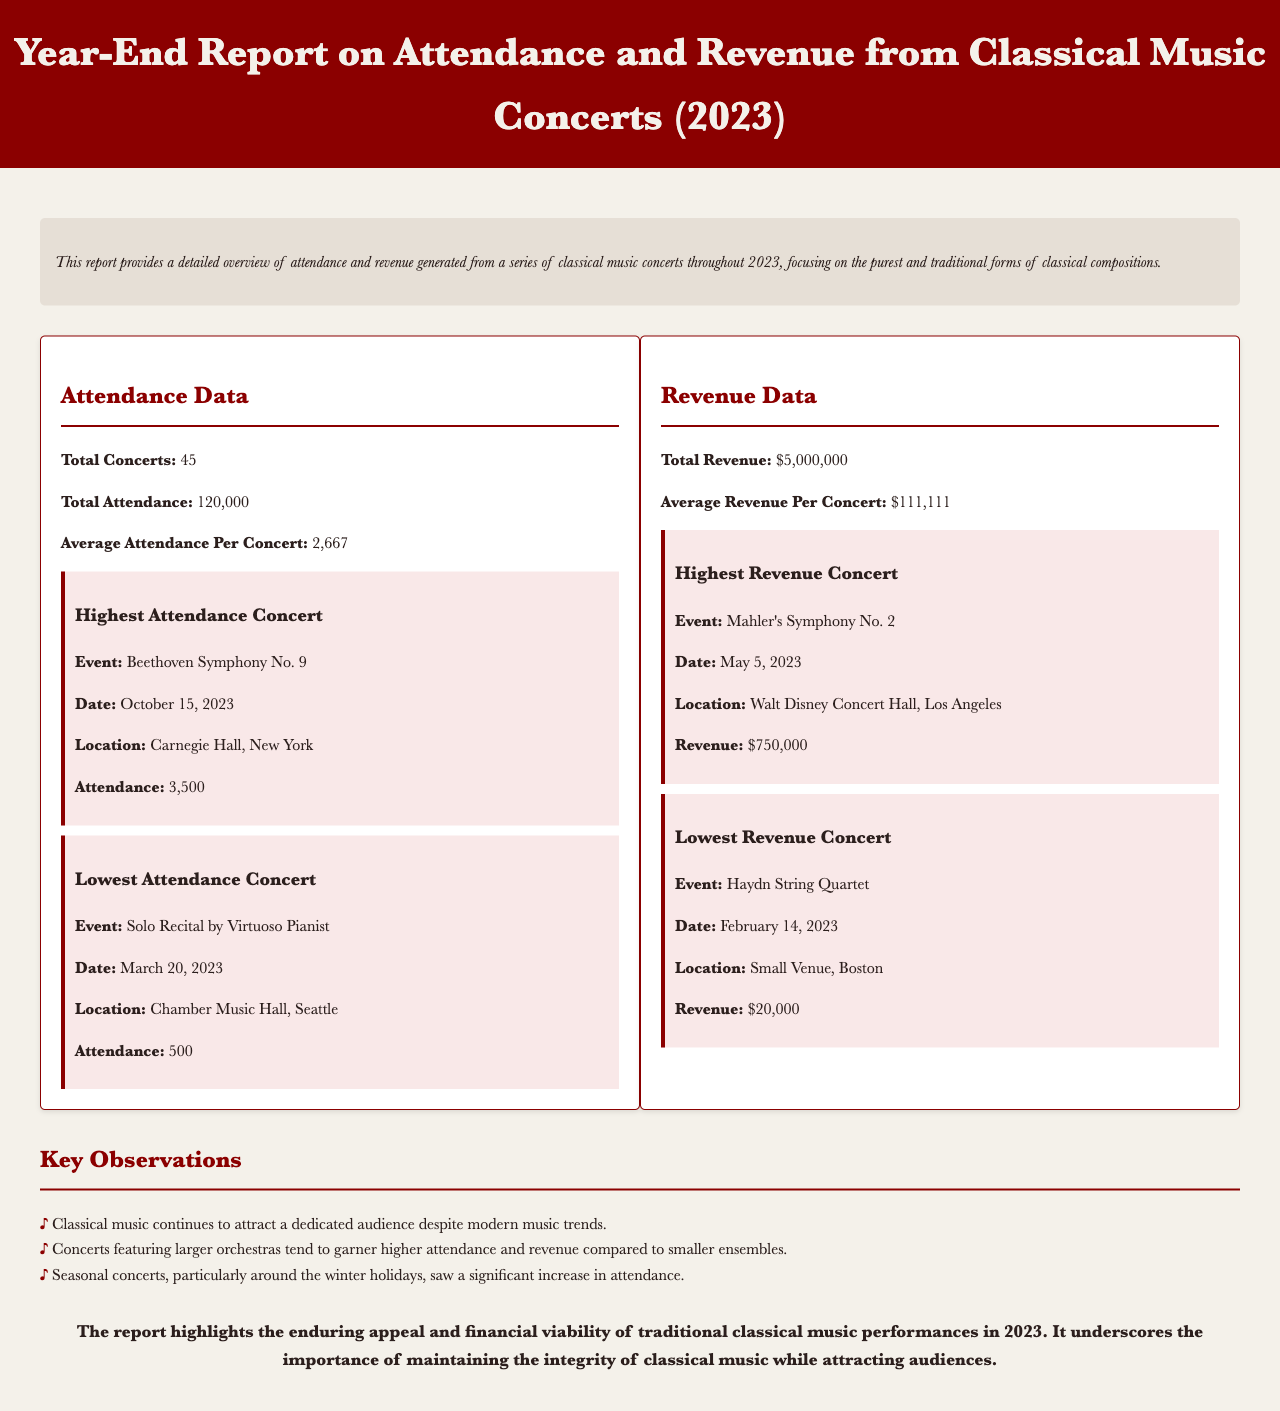What is the total number of concerts held? The report specifies that there were a total of 45 concerts throughout the year.
Answer: 45 What is the total attendance figure? The total attendance mentioned in the report is 120,000 attendees across all concerts.
Answer: 120,000 What was the highest attendance for a single concert? The highest attendance for a concert was for Beethoven's Symphony No. 9, with an attendance of 3,500.
Answer: 3,500 Which concert generated the highest revenue? The concert that generated the highest revenue was Mahler's Symphony No. 2, earning $750,000.
Answer: $750,000 What date was the lowest attendance concert held? The concert with the lowest attendance took place on March 20, 2023.
Answer: March 20, 2023 What is the average revenue per concert? The average revenue generated per concert is calculated to be $111,111 based on the total revenue.
Answer: $111,111 What trends were observed regarding concert attendance? The report notes that larger orchestras tend to attract higher attendance and revenue compared to smaller ensembles.
Answer: Larger orchestras attract higher attendance What was the total revenue earned from the concerts? The total revenue generated from all concerts throughout 2023 amounts to $5,000,000.
Answer: $5,000,000 What venue hosted the highest attendance concert? The highest attendance concert was held at Carnegie Hall, New York.
Answer: Carnegie Hall, New York 